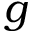<formula> <loc_0><loc_0><loc_500><loc_500>g</formula> 